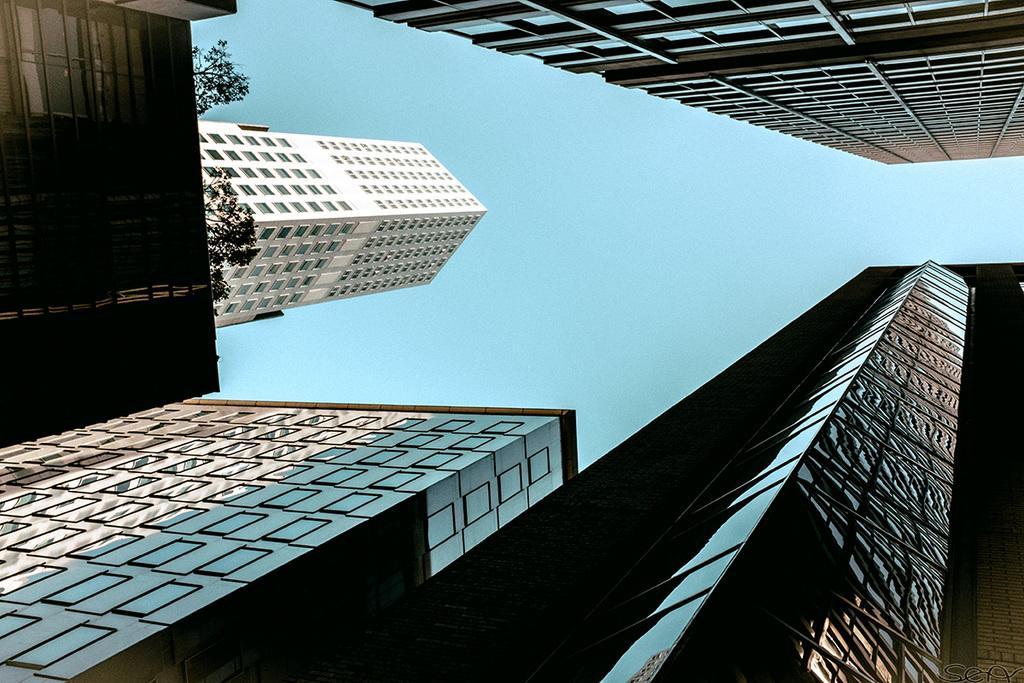Can you describe this image briefly? In this image at the top and bottom there are buildings. On the left there are trees. In the middle there is the sky. 